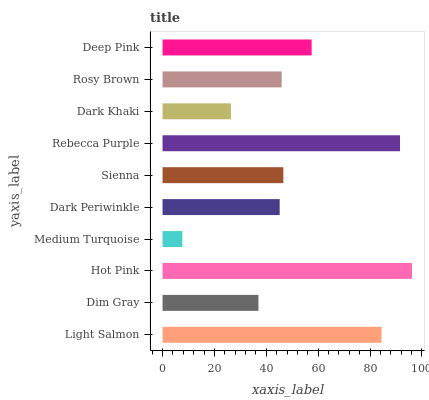Is Medium Turquoise the minimum?
Answer yes or no. Yes. Is Hot Pink the maximum?
Answer yes or no. Yes. Is Dim Gray the minimum?
Answer yes or no. No. Is Dim Gray the maximum?
Answer yes or no. No. Is Light Salmon greater than Dim Gray?
Answer yes or no. Yes. Is Dim Gray less than Light Salmon?
Answer yes or no. Yes. Is Dim Gray greater than Light Salmon?
Answer yes or no. No. Is Light Salmon less than Dim Gray?
Answer yes or no. No. Is Sienna the high median?
Answer yes or no. Yes. Is Rosy Brown the low median?
Answer yes or no. Yes. Is Light Salmon the high median?
Answer yes or no. No. Is Hot Pink the low median?
Answer yes or no. No. 